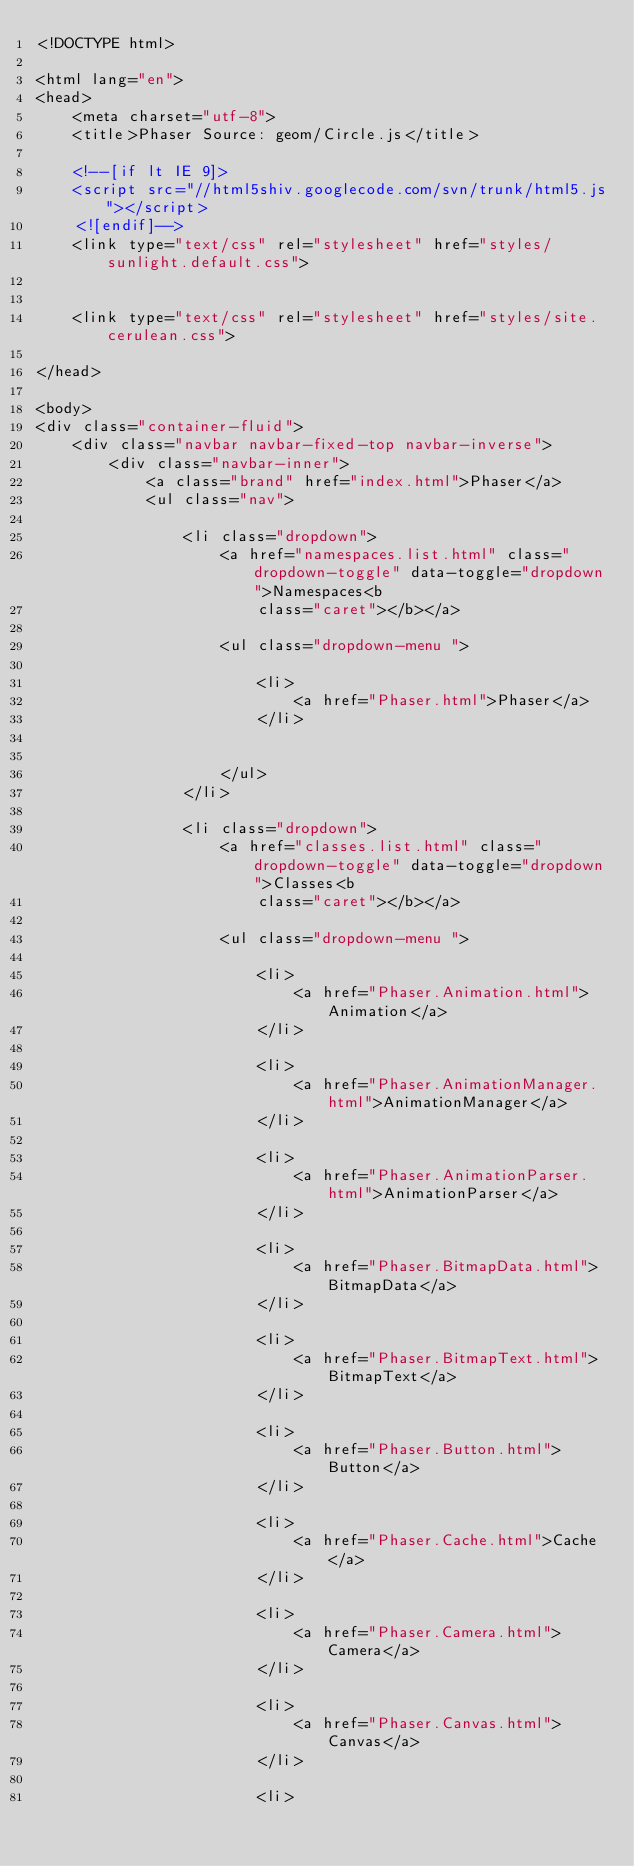Convert code to text. <code><loc_0><loc_0><loc_500><loc_500><_HTML_><!DOCTYPE html>

<html lang="en">
<head>
	<meta charset="utf-8">
	<title>Phaser Source: geom/Circle.js</title>

	<!--[if lt IE 9]>
	<script src="//html5shiv.googlecode.com/svn/trunk/html5.js"></script>
	<![endif]-->
	<link type="text/css" rel="stylesheet" href="styles/sunlight.default.css">

	
	<link type="text/css" rel="stylesheet" href="styles/site.cerulean.css">
	
</head>

<body>
<div class="container-fluid">
	<div class="navbar navbar-fixed-top navbar-inverse">
		<div class="navbar-inner">
			<a class="brand" href="index.html">Phaser</a>
			<ul class="nav">
				
				<li class="dropdown">
					<a href="namespaces.list.html" class="dropdown-toggle" data-toggle="dropdown">Namespaces<b
						class="caret"></b></a>

					<ul class="dropdown-menu ">
						
						<li>
							<a href="Phaser.html">Phaser</a>
						</li>
						

					</ul>
				</li>
				
				<li class="dropdown">
					<a href="classes.list.html" class="dropdown-toggle" data-toggle="dropdown">Classes<b
						class="caret"></b></a>

					<ul class="dropdown-menu ">
						
						<li>
							<a href="Phaser.Animation.html">Animation</a>
						</li>
						
						<li>
							<a href="Phaser.AnimationManager.html">AnimationManager</a>
						</li>
						
						<li>
							<a href="Phaser.AnimationParser.html">AnimationParser</a>
						</li>
						
						<li>
							<a href="Phaser.BitmapData.html">BitmapData</a>
						</li>
						
						<li>
							<a href="Phaser.BitmapText.html">BitmapText</a>
						</li>
						
						<li>
							<a href="Phaser.Button.html">Button</a>
						</li>
						
						<li>
							<a href="Phaser.Cache.html">Cache</a>
						</li>
						
						<li>
							<a href="Phaser.Camera.html">Camera</a>
						</li>
						
						<li>
							<a href="Phaser.Canvas.html">Canvas</a>
						</li>
						
						<li></code> 